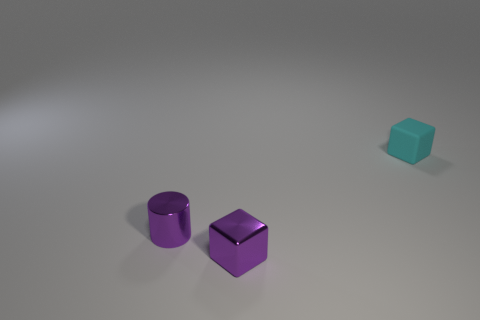Add 1 big blue shiny cubes. How many objects exist? 4 Subtract all cylinders. How many objects are left? 2 Add 1 tiny cyan blocks. How many tiny cyan blocks are left? 2 Add 2 tiny gray metal objects. How many tiny gray metal objects exist? 2 Subtract 1 purple blocks. How many objects are left? 2 Subtract all cubes. Subtract all tiny rubber cubes. How many objects are left? 0 